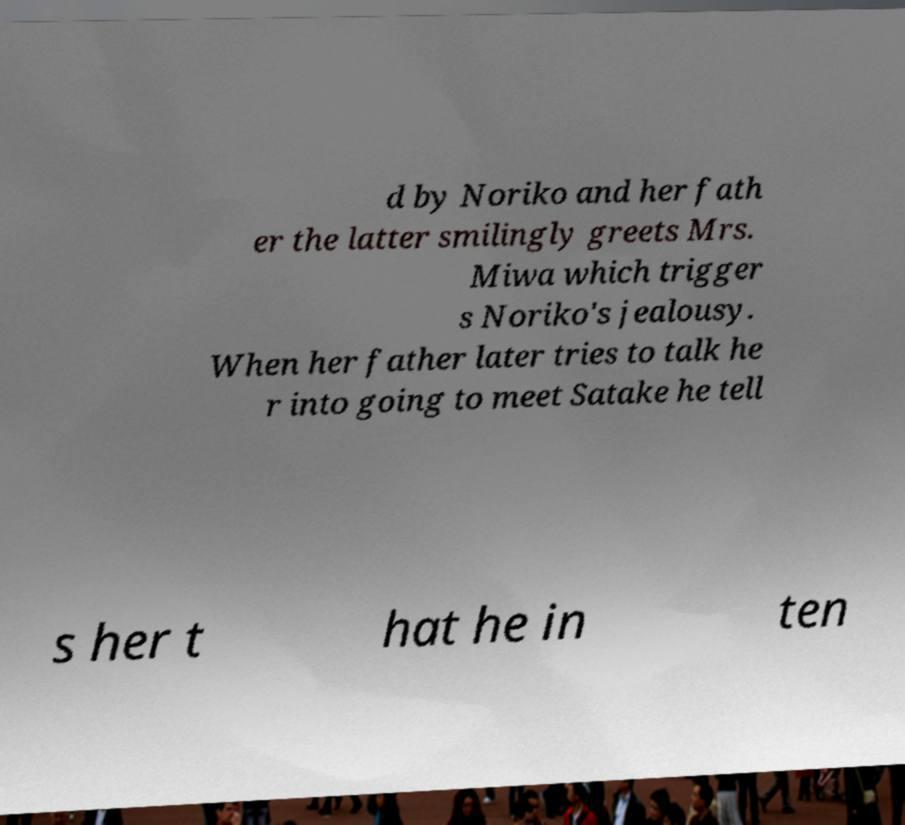Could you extract and type out the text from this image? d by Noriko and her fath er the latter smilingly greets Mrs. Miwa which trigger s Noriko's jealousy. When her father later tries to talk he r into going to meet Satake he tell s her t hat he in ten 